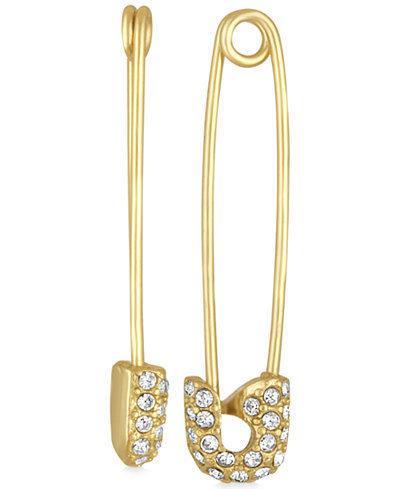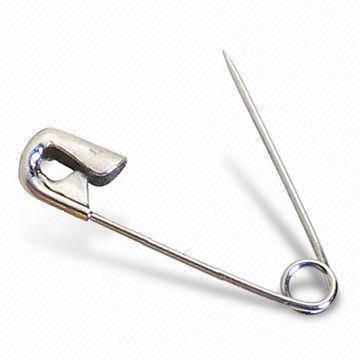The first image is the image on the left, the second image is the image on the right. Given the left and right images, does the statement "One pin in the image on the right is open." hold true? Answer yes or no. Yes. The first image is the image on the left, the second image is the image on the right. Considering the images on both sides, is "The left image contains no more than one gold safety pin." valid? Answer yes or no. No. 